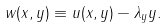<formula> <loc_0><loc_0><loc_500><loc_500>w ( x , y ) \equiv u ( x , y ) - \lambda _ { y } y .</formula> 